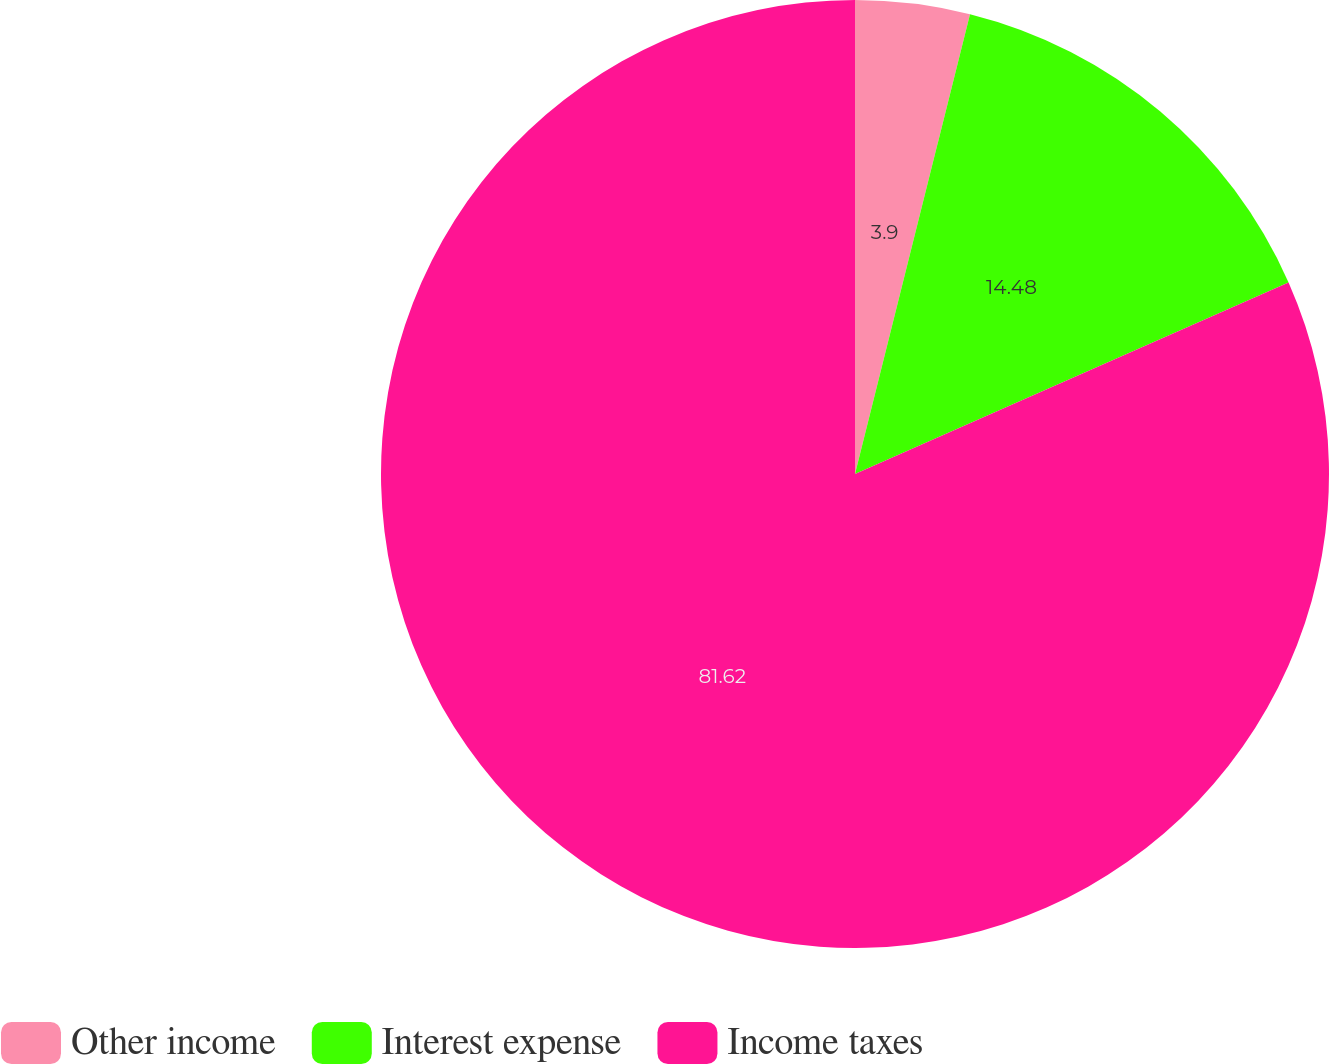<chart> <loc_0><loc_0><loc_500><loc_500><pie_chart><fcel>Other income<fcel>Interest expense<fcel>Income taxes<nl><fcel>3.9%<fcel>14.48%<fcel>81.63%<nl></chart> 